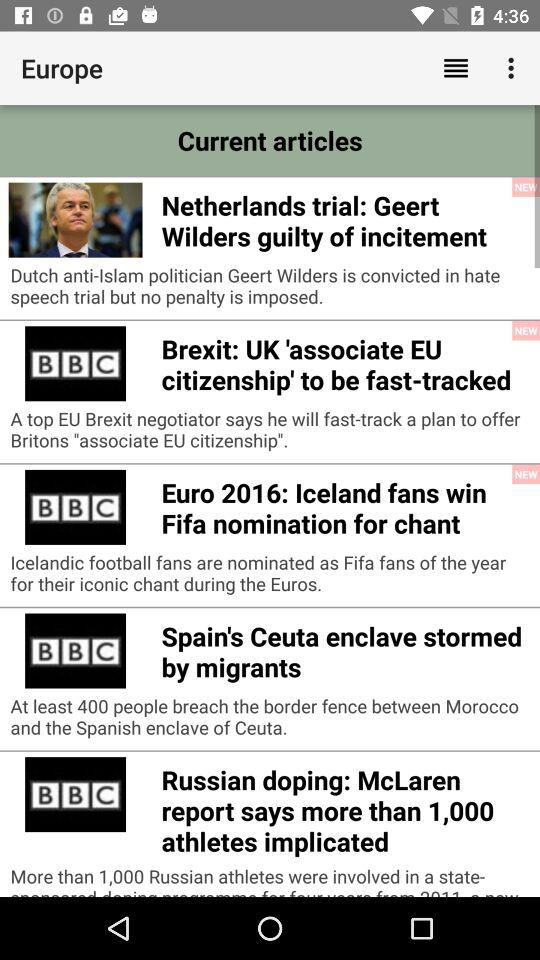How many of the articles are marked as 'NEW'?
Answer the question using a single word or phrase. 3 